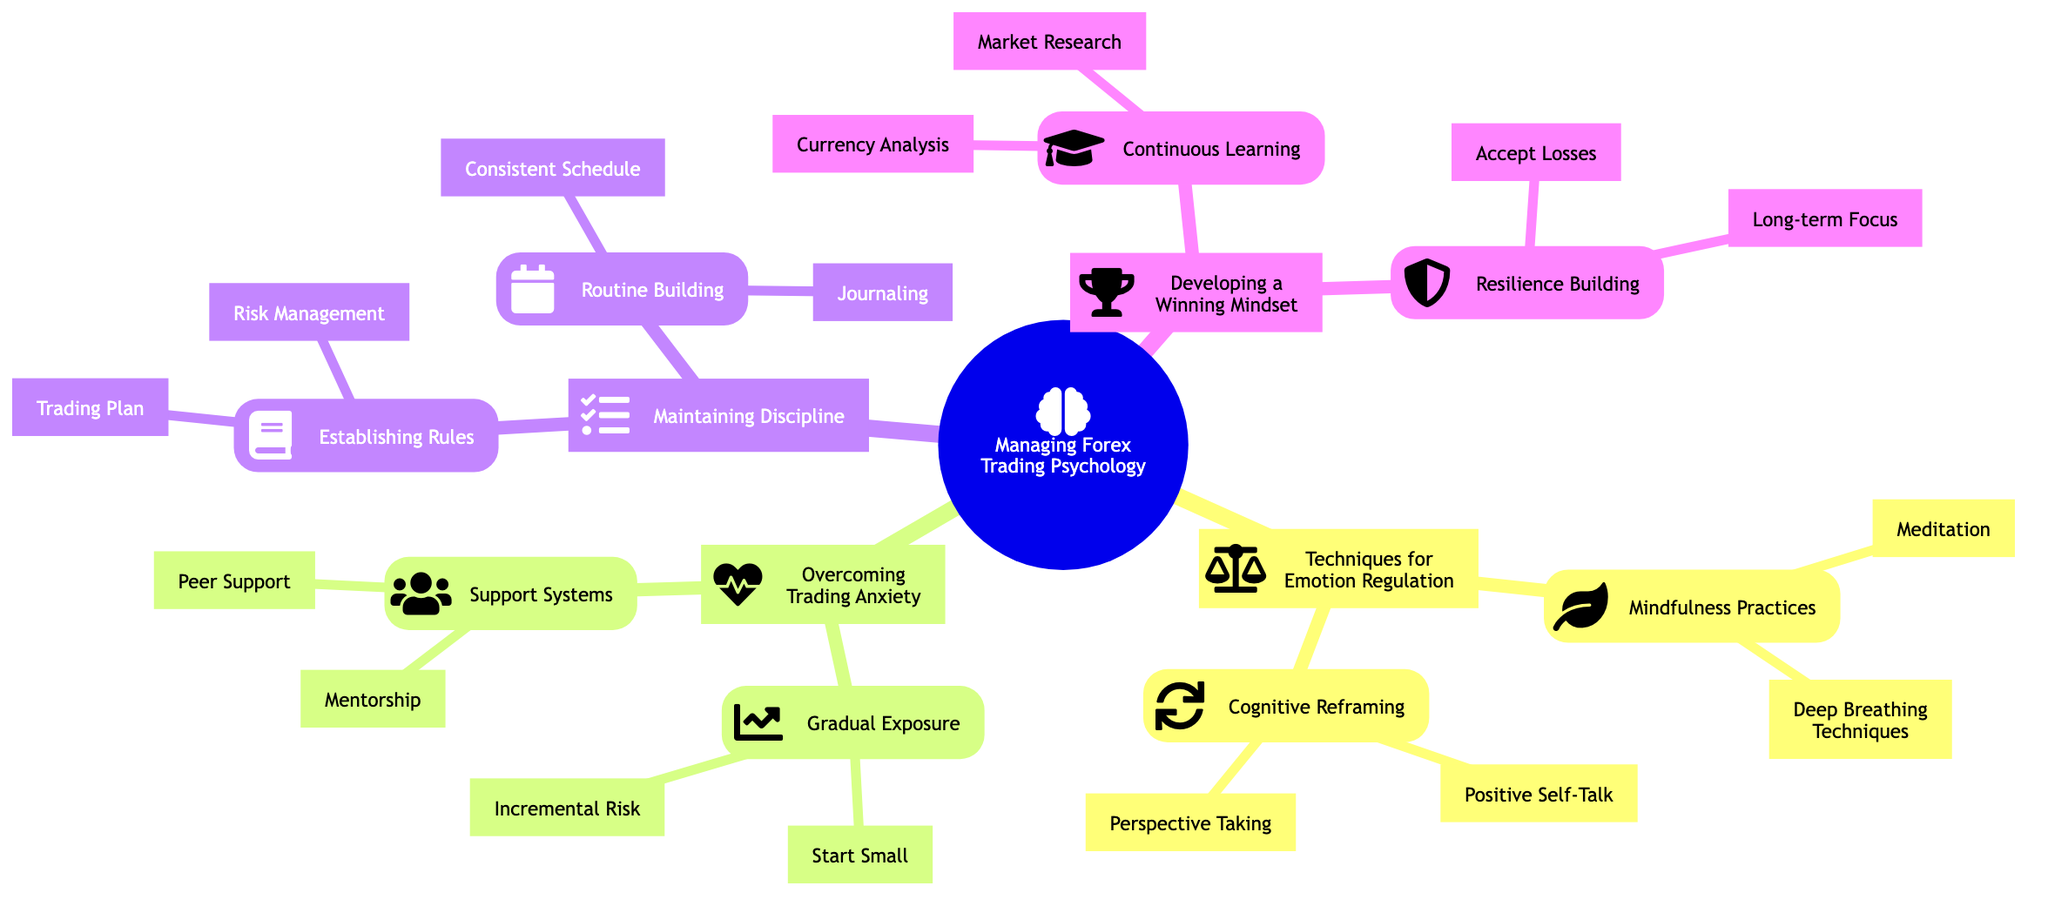What are the two main categories under "Techniques for Emotion Regulation"? The diagram lists "Mindfulness Practices" and "Cognitive Reframing" as the two main categories under "Techniques for Emotion Regulation," both of which focus on managing emotions while trading.
Answer: Mindfulness Practices, Cognitive Reframing How many techniques are displayed under "Overcoming Trading Anxiety"? The diagram shows two primary techniques under "Overcoming Trading Anxiety": "Gradual Exposure" and "Support Systems." Each has two specific strategies listed beneath them, leading to a total of four techniques overall.
Answer: 4 What is the primary focus of "Resilience Building"? The diagram indicates that "Resilience Building" focuses on two key aspects: "Accept Losses" and "Long-term Focus," both of which contribute to developing a resilient mindset.
Answer: Accept Losses, Long-term Focus What strategy is recommended for "Routine Building"? Under the "Routine Building" category, the diagram suggests "Consistent Schedule" and "Journaling" as strategies to maintain discipline in trading behavior.
Answer: Consistent Schedule, Journaling What two practices are listed under "Mindfulness Practices"? The diagram specifies "Meditation" and "Deep Breathing Techniques" as the practices categorized under "Mindfulness Practices," highlighting techniques for reducing trading-related stress.
Answer: Meditation, Deep Breathing Techniques Which category includes "Trading Plan"? The "Trading Plan" is found under "Establishing Rules," a subcategory of "Maintaining Discipline," which emphasizes the importance of creating and adhering to specific trading guidelines.
Answer: Establishing Rules What is the purpose of "Incremental Risk"? "Incremental Risk" is referenced as a strategy under "Gradual Exposure," meant to help traders build confidence by gradually increasing the volumes they trade as they become more comfortable.
Answer: Build confidence What is the connection between "Peer Support" and "Support Systems"? "Peer Support" is categorized under "Support Systems," indicating that it is a method for overcoming trading anxiety by leveraging the collective experience and strategies of fellow traders.
Answer: Category relationship How can "Positive Self-Talk" contribute to emotion regulation in trading? "Positive Self-Talk" is a technique listed under "Cognitive Reframing" which aims to replace negative thoughts with affirming ones, thereby helping traders manage their emotions and anxiety while trading.
Answer: Manage emotions 